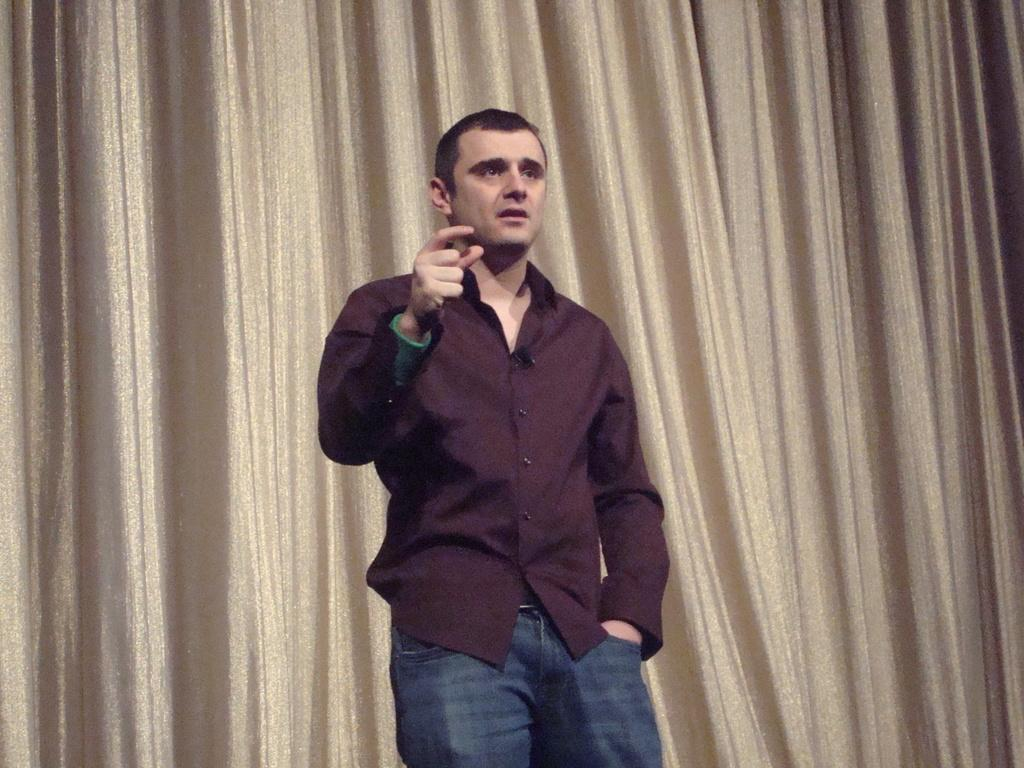What is the main subject of the image? There is a man standing in the image. What is the man wearing? The man is wearing a shirt and jeans trousers. What is the man doing with his hand? The man is pointing his hand behind him. What type of fabric or material is visible in the image? There is a curtain visible in the image. What type of stone can be seen on the stage in the image? There is no stage or stone present in the image; it features a man standing and pointing his hand behind him, with a curtain visible. 